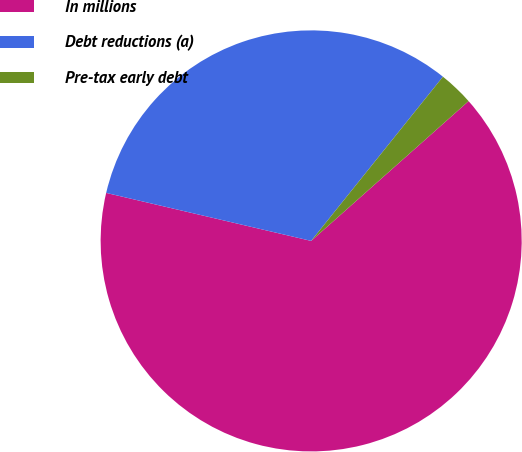Convert chart. <chart><loc_0><loc_0><loc_500><loc_500><pie_chart><fcel>In millions<fcel>Debt reductions (a)<fcel>Pre-tax early debt<nl><fcel>65.21%<fcel>32.1%<fcel>2.68%<nl></chart> 